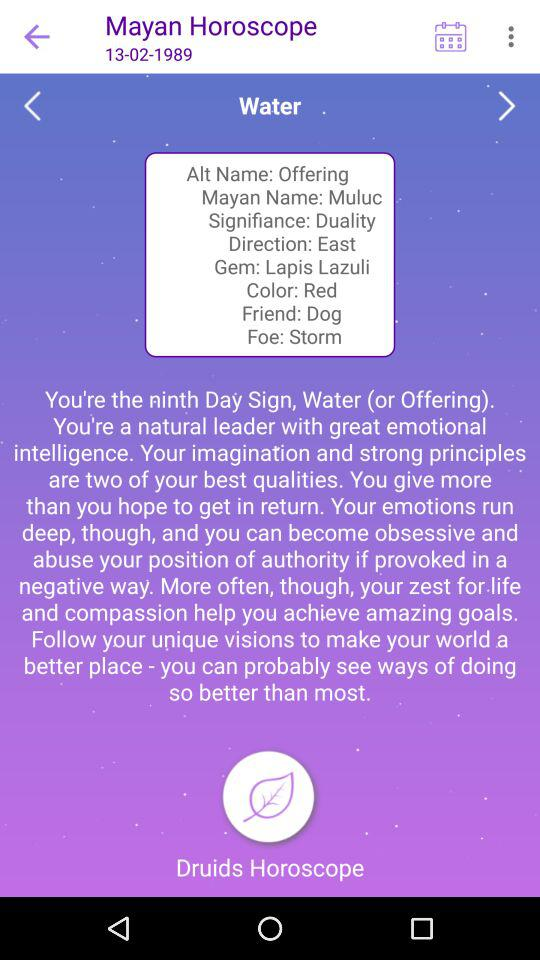What is the "Signifiance"? The Signifiance is duality. 